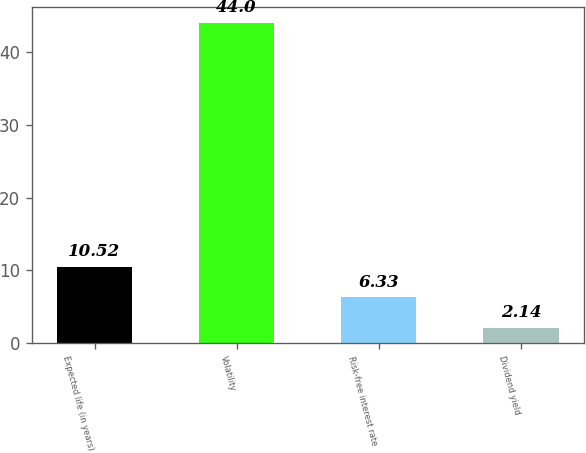Convert chart to OTSL. <chart><loc_0><loc_0><loc_500><loc_500><bar_chart><fcel>Expected life (in years)<fcel>Volatility<fcel>Risk-free interest rate<fcel>Dividend yield<nl><fcel>10.52<fcel>44<fcel>6.33<fcel>2.14<nl></chart> 